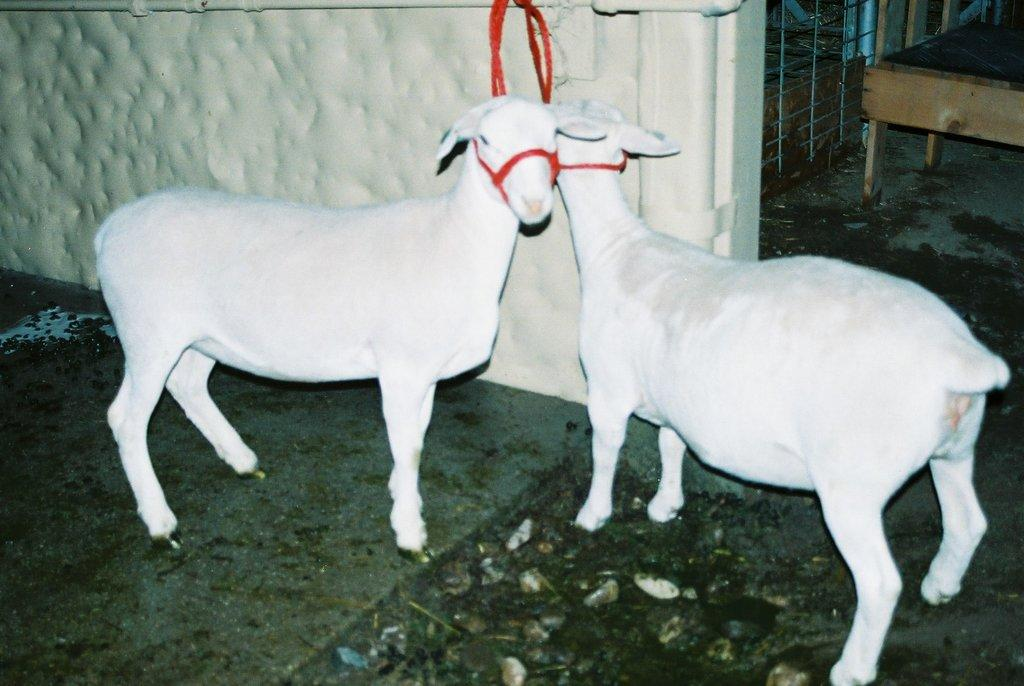How many goats are in the image? There are 2 white goats in the image. What are the goats doing in the image? The goats are standing in the image. How are the goats secured in the image? The goats are tied to a red rope. What can be seen in the background of the image? There is a white wall in the image. What type of dress is the goat wearing in the image? There are no goats wearing dresses in the image; they are not dressed in any clothing. 